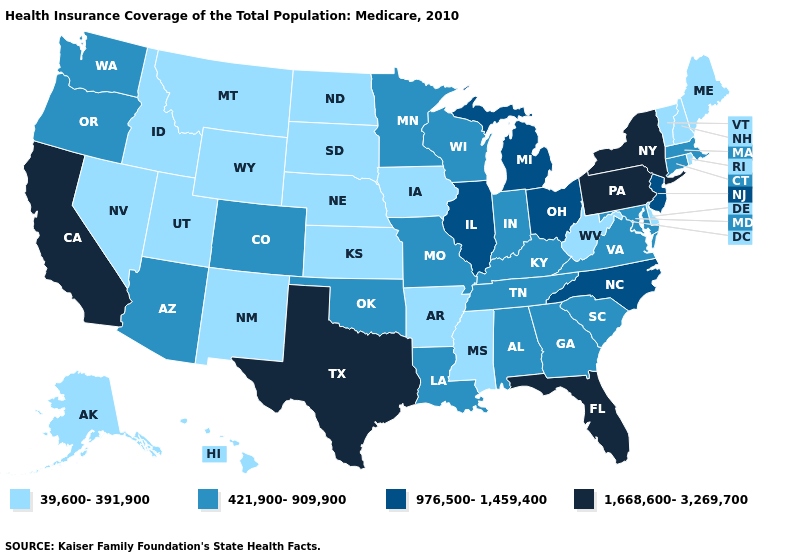Which states hav the highest value in the West?
Be succinct. California. Does the first symbol in the legend represent the smallest category?
Keep it brief. Yes. Does Oregon have the same value as Alaska?
Quick response, please. No. Which states hav the highest value in the West?
Concise answer only. California. What is the highest value in the USA?
Keep it brief. 1,668,600-3,269,700. What is the highest value in the USA?
Quick response, please. 1,668,600-3,269,700. Does Oregon have the highest value in the USA?
Keep it brief. No. Name the states that have a value in the range 39,600-391,900?
Quick response, please. Alaska, Arkansas, Delaware, Hawaii, Idaho, Iowa, Kansas, Maine, Mississippi, Montana, Nebraska, Nevada, New Hampshire, New Mexico, North Dakota, Rhode Island, South Dakota, Utah, Vermont, West Virginia, Wyoming. Does New York have the highest value in the Northeast?
Answer briefly. Yes. Does Michigan have a higher value than California?
Be succinct. No. Among the states that border Pennsylvania , does Delaware have the highest value?
Concise answer only. No. Name the states that have a value in the range 421,900-909,900?
Be succinct. Alabama, Arizona, Colorado, Connecticut, Georgia, Indiana, Kentucky, Louisiana, Maryland, Massachusetts, Minnesota, Missouri, Oklahoma, Oregon, South Carolina, Tennessee, Virginia, Washington, Wisconsin. What is the lowest value in states that border Louisiana?
Give a very brief answer. 39,600-391,900. What is the highest value in states that border Wisconsin?
Short answer required. 976,500-1,459,400. Name the states that have a value in the range 1,668,600-3,269,700?
Give a very brief answer. California, Florida, New York, Pennsylvania, Texas. 